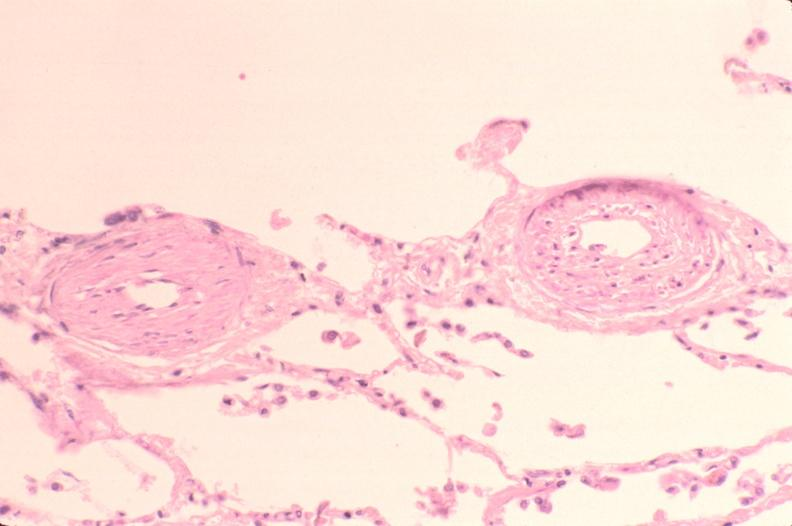what does this image show?
Answer the question using a single word or phrase. Lung 